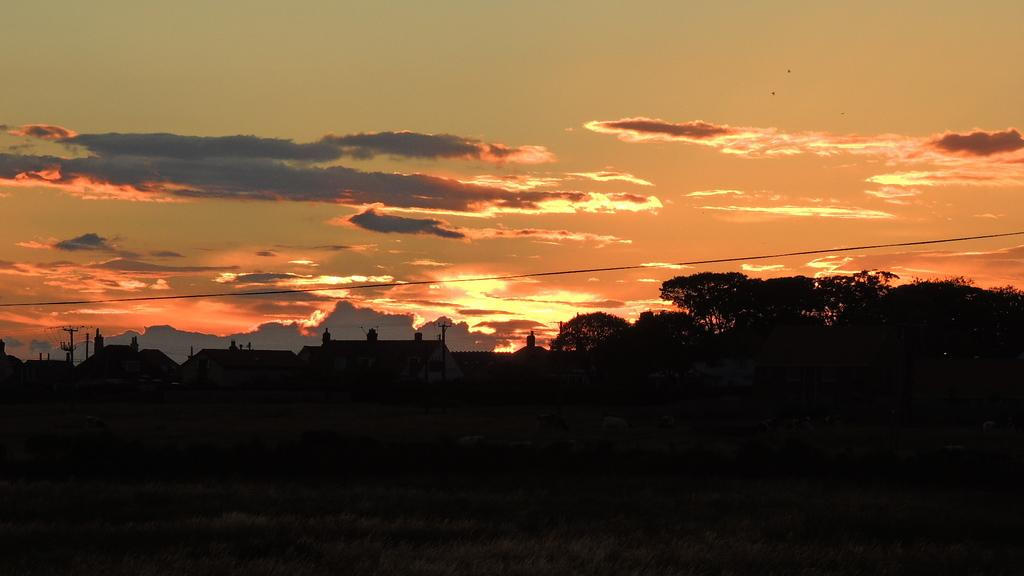What type of structures can be seen in the image? There are buildings in the image. What natural elements are present in the image? There are trees in the image. What man-made objects can be seen in the image? There are electric poles in the image. What is visible in the background of the image? The sky is visible in the background of the image. What atmospheric conditions can be observed in the sky? Clouds are present in the sky. How would you describe the overall lighting in the image? The image appears to be dark. How many people are in the crowd in the image? There is no crowd present in the image; it features buildings, trees, electric poles, and a sky with clouds. What type of secretary is shown working in the image? There is no secretary present in the image. 